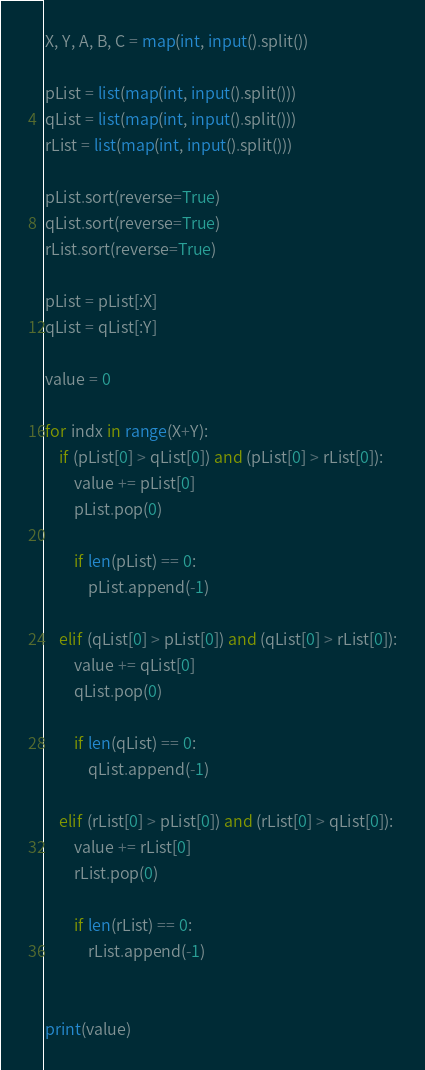Convert code to text. <code><loc_0><loc_0><loc_500><loc_500><_Python_>X, Y, A, B, C = map(int, input().split())

pList = list(map(int, input().split()))
qList = list(map(int, input().split()))
rList = list(map(int, input().split()))

pList.sort(reverse=True)
qList.sort(reverse=True)
rList.sort(reverse=True)

pList = pList[:X]
qList = qList[:Y]

value = 0

for indx in range(X+Y):
    if (pList[0] > qList[0]) and (pList[0] > rList[0]):
        value += pList[0]
        pList.pop(0)

        if len(pList) == 0:
            pList.append(-1)

    elif (qList[0] > pList[0]) and (qList[0] > rList[0]):
        value += qList[0]
        qList.pop(0)

        if len(qList) == 0:
            qList.append(-1)

    elif (rList[0] > pList[0]) and (rList[0] > qList[0]):
        value += rList[0]
        rList.pop(0)

        if len(rList) == 0:
            rList.append(-1)


print(value)
</code> 